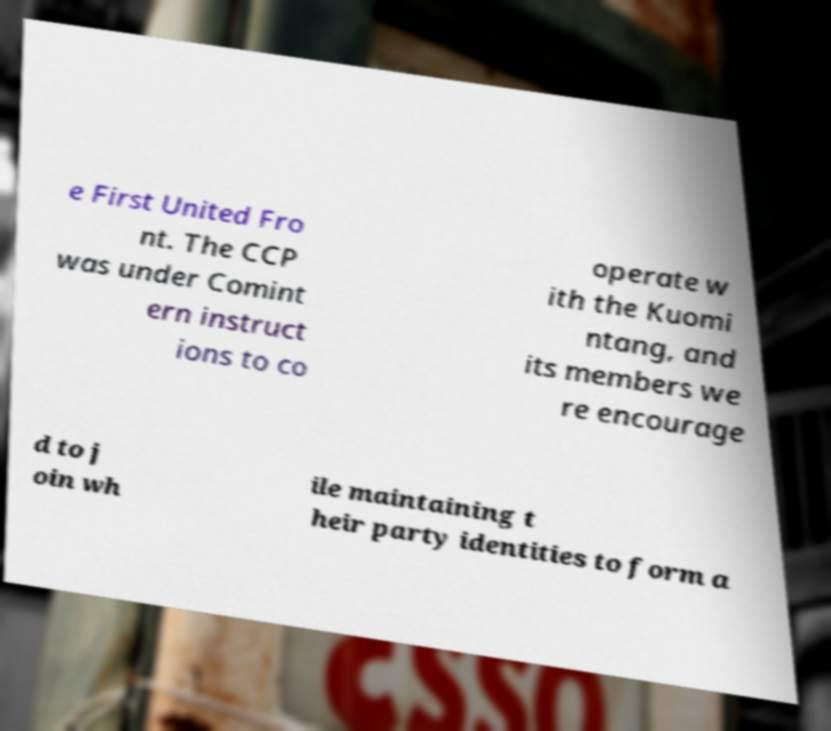Could you assist in decoding the text presented in this image and type it out clearly? e First United Fro nt. The CCP was under Comint ern instruct ions to co operate w ith the Kuomi ntang, and its members we re encourage d to j oin wh ile maintaining t heir party identities to form a 